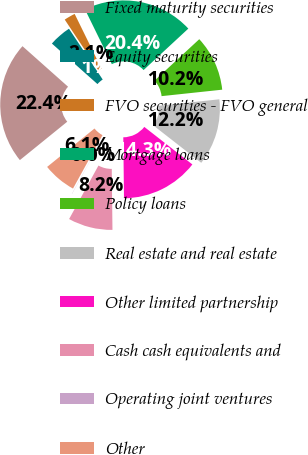Convert chart to OTSL. <chart><loc_0><loc_0><loc_500><loc_500><pie_chart><fcel>Fixed maturity securities<fcel>Equity securities<fcel>FVO securities - FVO general<fcel>Mortgage loans<fcel>Policy loans<fcel>Real estate and real estate<fcel>Other limited partnership<fcel>Cash cash equivalents and<fcel>Operating joint ventures<fcel>Other<nl><fcel>22.41%<fcel>4.1%<fcel>2.07%<fcel>20.37%<fcel>10.2%<fcel>12.24%<fcel>14.27%<fcel>8.17%<fcel>0.03%<fcel>6.14%<nl></chart> 